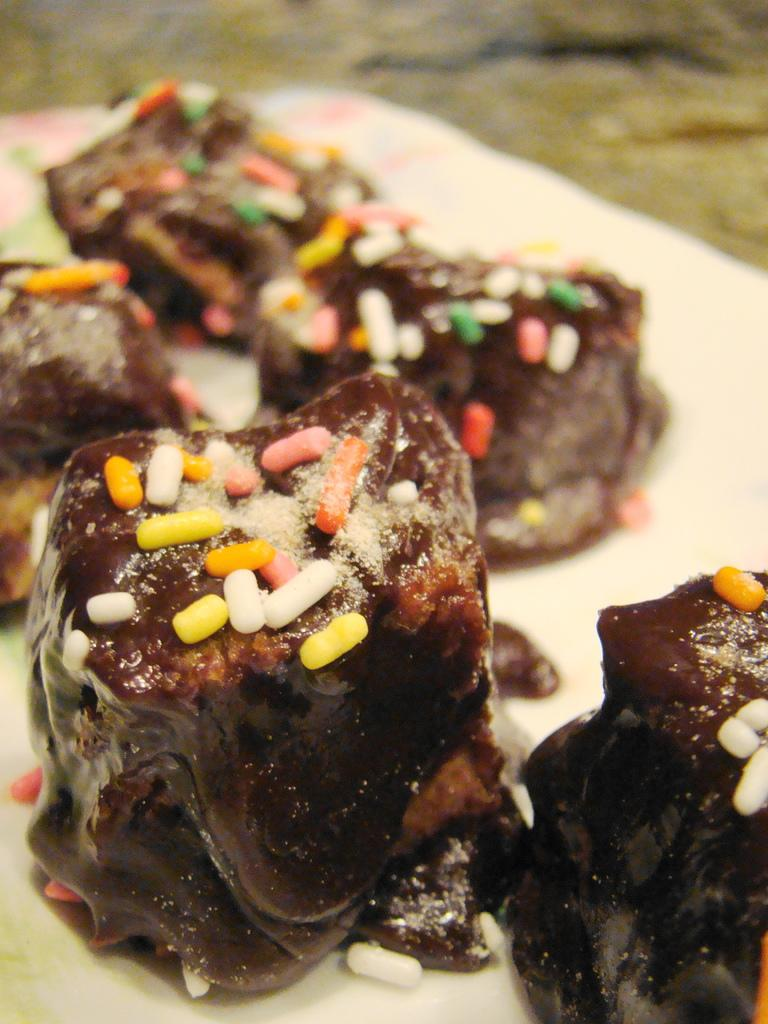What is present in the image related to food? There is food in the image. How is the food arranged or displayed in the image? The food is in a plate. What type of mist can be seen surrounding the food in the image? There is no mist present in the image; it only shows food in a plate. 